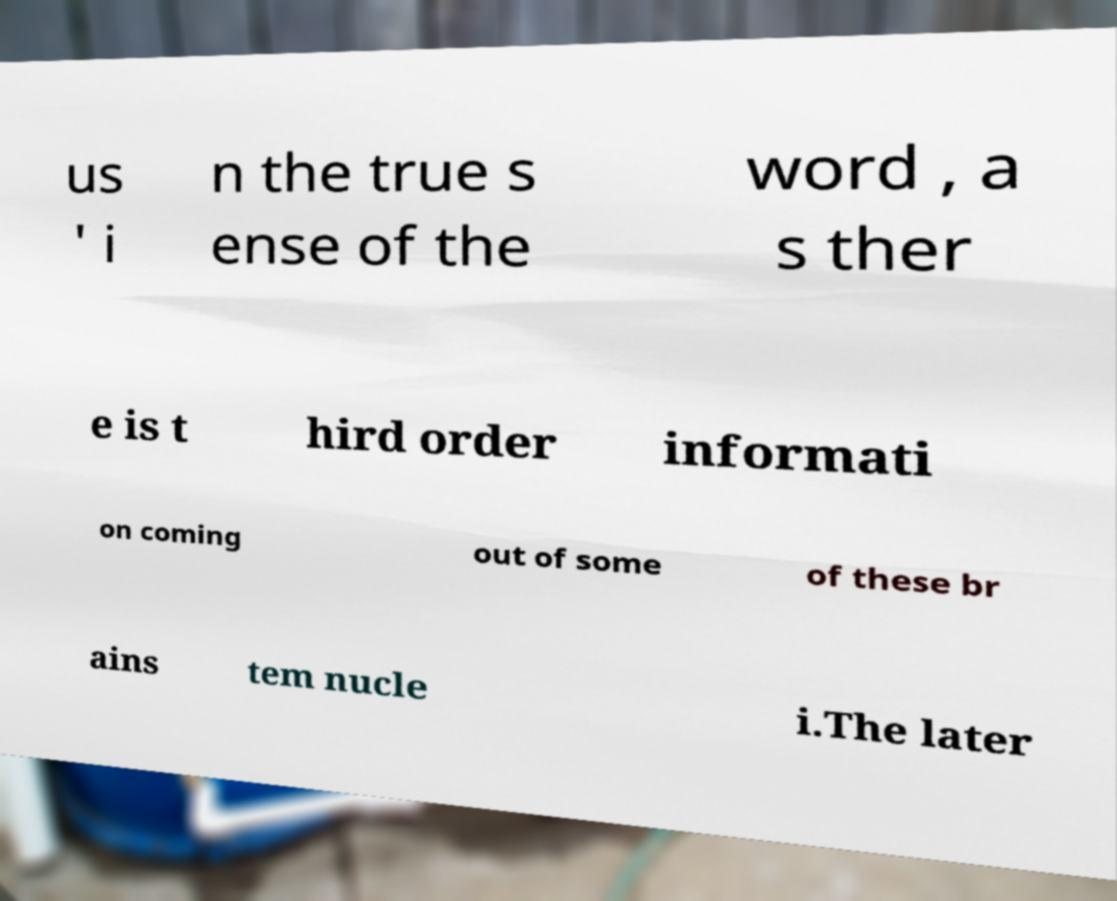I need the written content from this picture converted into text. Can you do that? us ' i n the true s ense of the word , a s ther e is t hird order informati on coming out of some of these br ains tem nucle i.The later 